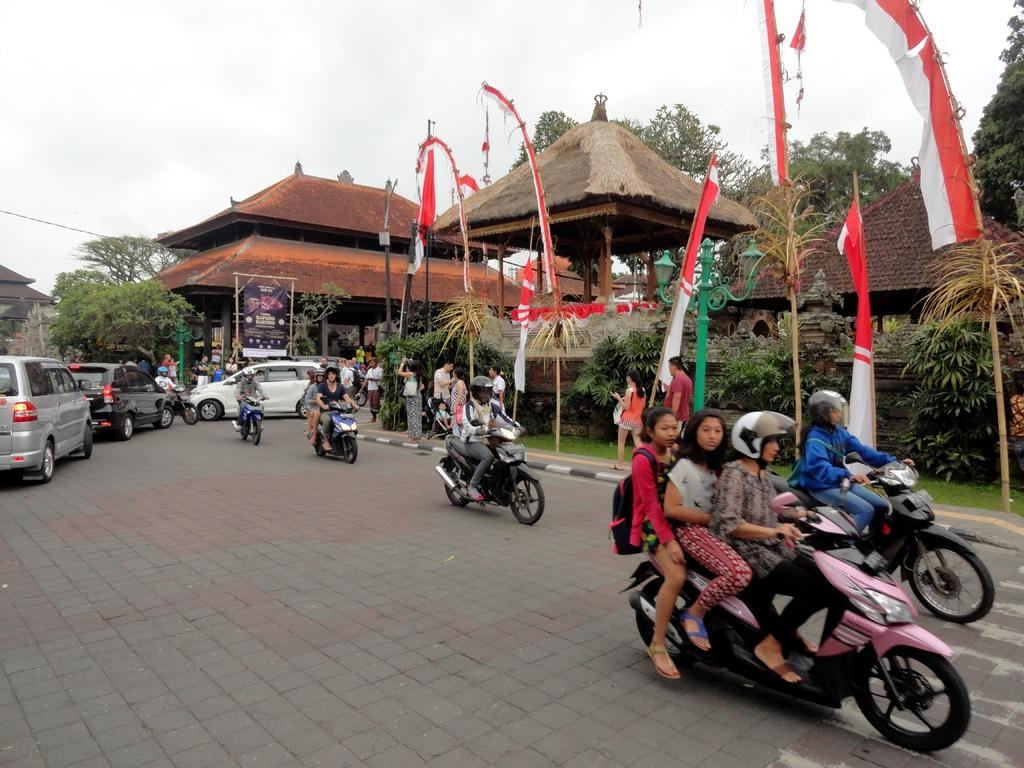What are the people in the image doing? The people in the image are riding bikes. What else is happening in the image besides people riding bikes? There are cars moving on the road in the image. What can be seen in the background of the image? There are trees, buildings, and flags in the background of the image. How would you describe the weather in the image? The sky is clear in the image, suggesting good weather. What type of clock is hanging on the tree in the image? There is no clock present in the image; it features people riding bikes, cars moving on the road, and various background elements. 